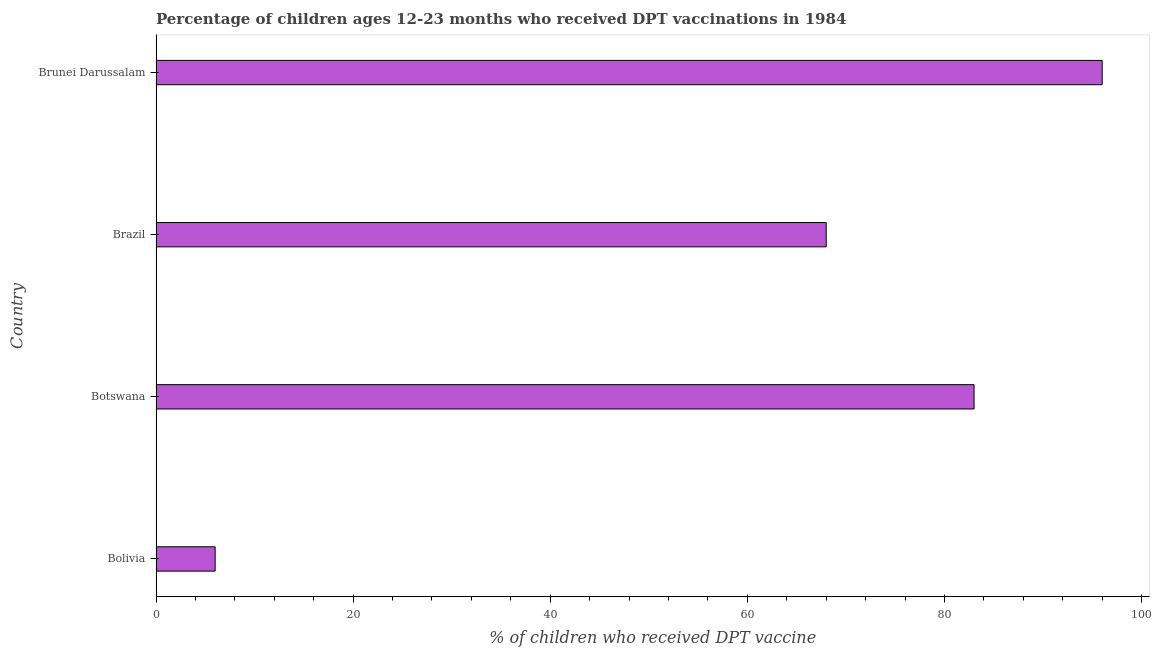Does the graph contain any zero values?
Keep it short and to the point. No. What is the title of the graph?
Your response must be concise. Percentage of children ages 12-23 months who received DPT vaccinations in 1984. What is the label or title of the X-axis?
Offer a very short reply. % of children who received DPT vaccine. Across all countries, what is the maximum percentage of children who received dpt vaccine?
Provide a succinct answer. 96. In which country was the percentage of children who received dpt vaccine maximum?
Your response must be concise. Brunei Darussalam. In which country was the percentage of children who received dpt vaccine minimum?
Offer a very short reply. Bolivia. What is the sum of the percentage of children who received dpt vaccine?
Your answer should be compact. 253. What is the difference between the percentage of children who received dpt vaccine in Botswana and Brazil?
Keep it short and to the point. 15. What is the average percentage of children who received dpt vaccine per country?
Your answer should be compact. 63.25. What is the median percentage of children who received dpt vaccine?
Your response must be concise. 75.5. In how many countries, is the percentage of children who received dpt vaccine greater than 96 %?
Give a very brief answer. 0. What is the ratio of the percentage of children who received dpt vaccine in Botswana to that in Brazil?
Provide a succinct answer. 1.22. Is the sum of the percentage of children who received dpt vaccine in Bolivia and Brazil greater than the maximum percentage of children who received dpt vaccine across all countries?
Your answer should be very brief. No. What is the difference between the highest and the lowest percentage of children who received dpt vaccine?
Your response must be concise. 90. Are all the bars in the graph horizontal?
Provide a succinct answer. Yes. What is the % of children who received DPT vaccine of Bolivia?
Your answer should be very brief. 6. What is the % of children who received DPT vaccine in Botswana?
Offer a terse response. 83. What is the % of children who received DPT vaccine of Brazil?
Offer a terse response. 68. What is the % of children who received DPT vaccine of Brunei Darussalam?
Keep it short and to the point. 96. What is the difference between the % of children who received DPT vaccine in Bolivia and Botswana?
Offer a very short reply. -77. What is the difference between the % of children who received DPT vaccine in Bolivia and Brazil?
Make the answer very short. -62. What is the difference between the % of children who received DPT vaccine in Bolivia and Brunei Darussalam?
Provide a short and direct response. -90. What is the difference between the % of children who received DPT vaccine in Botswana and Brazil?
Provide a short and direct response. 15. What is the difference between the % of children who received DPT vaccine in Brazil and Brunei Darussalam?
Give a very brief answer. -28. What is the ratio of the % of children who received DPT vaccine in Bolivia to that in Botswana?
Your answer should be very brief. 0.07. What is the ratio of the % of children who received DPT vaccine in Bolivia to that in Brazil?
Offer a terse response. 0.09. What is the ratio of the % of children who received DPT vaccine in Bolivia to that in Brunei Darussalam?
Offer a terse response. 0.06. What is the ratio of the % of children who received DPT vaccine in Botswana to that in Brazil?
Your response must be concise. 1.22. What is the ratio of the % of children who received DPT vaccine in Botswana to that in Brunei Darussalam?
Keep it short and to the point. 0.86. What is the ratio of the % of children who received DPT vaccine in Brazil to that in Brunei Darussalam?
Give a very brief answer. 0.71. 